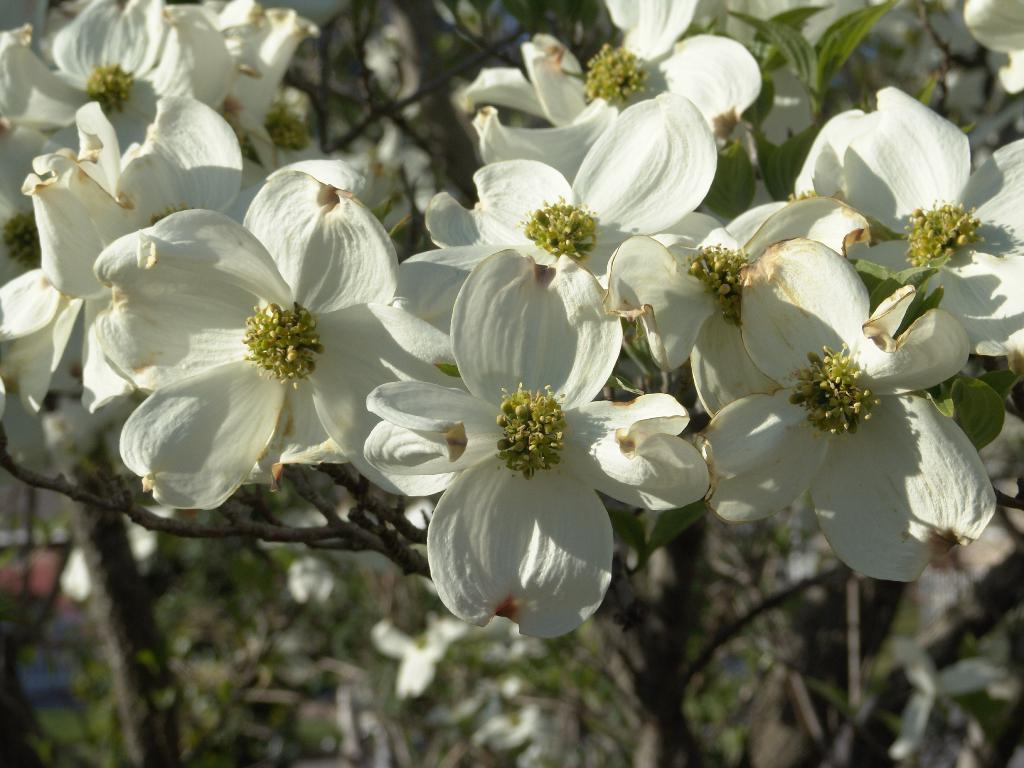What type of living organisms can be seen in the image? There are flowers in the image. What color are the flowers in the image? The flowers are white in color. What type of territory is being claimed by the flowers in the image? The flowers in the image are not claiming any territory; they are simply flowers. What afterthought might have been added to the flowers in the image? There is no mention of any afterthought added to the flowers in the image. What type of beverage is being served alongside the flowers in the image? There is no mention of any beverage, such as eggnog, in the image. 